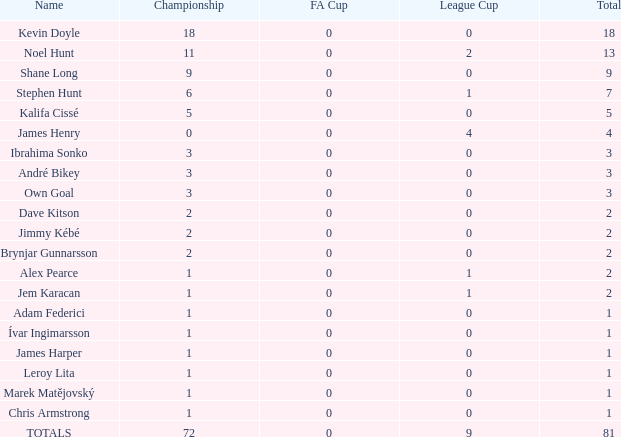What is the total championships that the league cup is less than 0? None. 